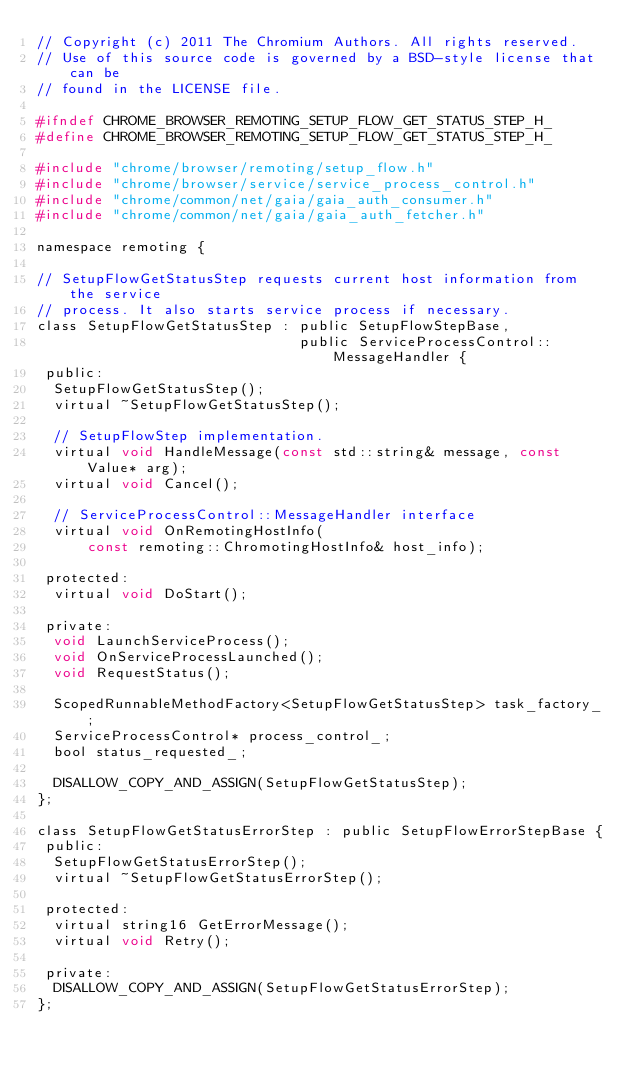Convert code to text. <code><loc_0><loc_0><loc_500><loc_500><_C_>// Copyright (c) 2011 The Chromium Authors. All rights reserved.
// Use of this source code is governed by a BSD-style license that can be
// found in the LICENSE file.

#ifndef CHROME_BROWSER_REMOTING_SETUP_FLOW_GET_STATUS_STEP_H_
#define CHROME_BROWSER_REMOTING_SETUP_FLOW_GET_STATUS_STEP_H_

#include "chrome/browser/remoting/setup_flow.h"
#include "chrome/browser/service/service_process_control.h"
#include "chrome/common/net/gaia/gaia_auth_consumer.h"
#include "chrome/common/net/gaia/gaia_auth_fetcher.h"

namespace remoting {

// SetupFlowGetStatusStep requests current host information from the service
// process. It also starts service process if necessary.
class SetupFlowGetStatusStep : public SetupFlowStepBase,
                               public ServiceProcessControl::MessageHandler {
 public:
  SetupFlowGetStatusStep();
  virtual ~SetupFlowGetStatusStep();

  // SetupFlowStep implementation.
  virtual void HandleMessage(const std::string& message, const Value* arg);
  virtual void Cancel();

  // ServiceProcessControl::MessageHandler interface
  virtual void OnRemotingHostInfo(
      const remoting::ChromotingHostInfo& host_info);

 protected:
  virtual void DoStart();

 private:
  void LaunchServiceProcess();
  void OnServiceProcessLaunched();
  void RequestStatus();

  ScopedRunnableMethodFactory<SetupFlowGetStatusStep> task_factory_;
  ServiceProcessControl* process_control_;
  bool status_requested_;

  DISALLOW_COPY_AND_ASSIGN(SetupFlowGetStatusStep);
};

class SetupFlowGetStatusErrorStep : public SetupFlowErrorStepBase {
 public:
  SetupFlowGetStatusErrorStep();
  virtual ~SetupFlowGetStatusErrorStep();

 protected:
  virtual string16 GetErrorMessage();
  virtual void Retry();

 private:
  DISALLOW_COPY_AND_ASSIGN(SetupFlowGetStatusErrorStep);
};
</code> 